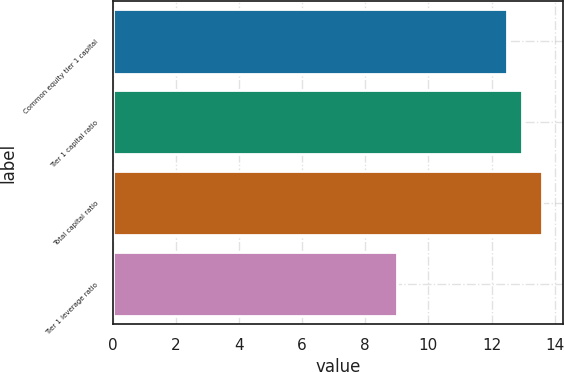Convert chart to OTSL. <chart><loc_0><loc_0><loc_500><loc_500><bar_chart><fcel>Common equity tier 1 capital<fcel>Tier 1 capital ratio<fcel>Total capital ratio<fcel>Tier 1 leverage ratio<nl><fcel>12.5<fcel>12.96<fcel>13.6<fcel>9<nl></chart> 